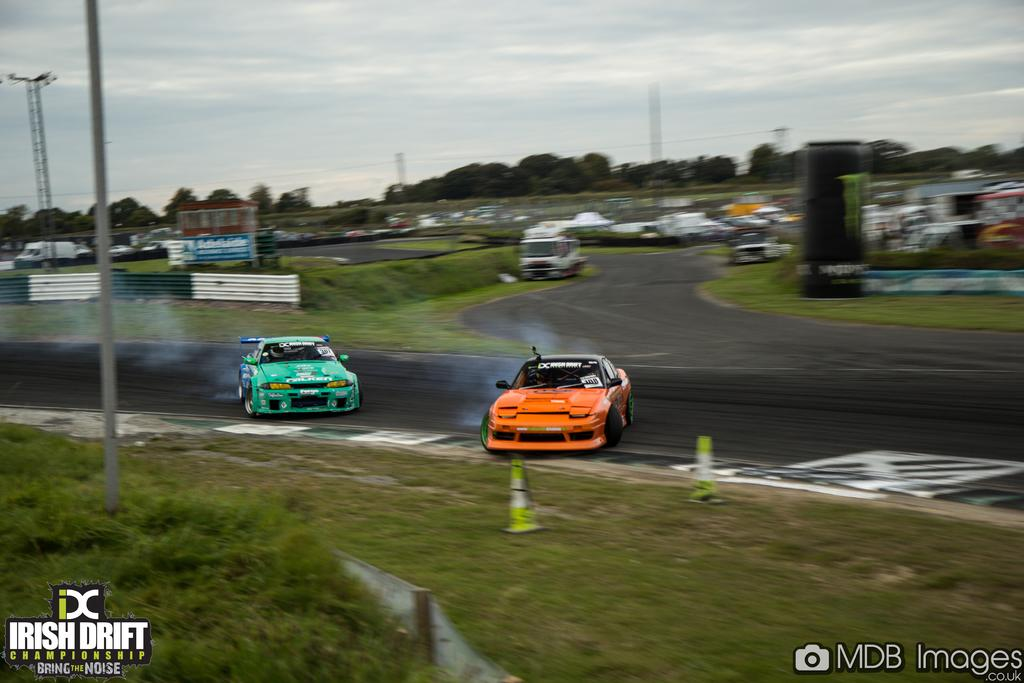What type of vehicles are present in the image? There are two racing cars on the road in the image. What else can be seen in the image besides the racing cars? There are trees, poles, and the sky visible in the image. Can you describe the road in the image? The road is where the racing cars are located. Is there any text or marking at the bottom of the image? Yes, there is a watermark at the bottom of the image. What type of nail is being used to hold the plate in the image? There is no nail or plate present in the image; it features two racing cars on the road, trees, poles, and the sky. 